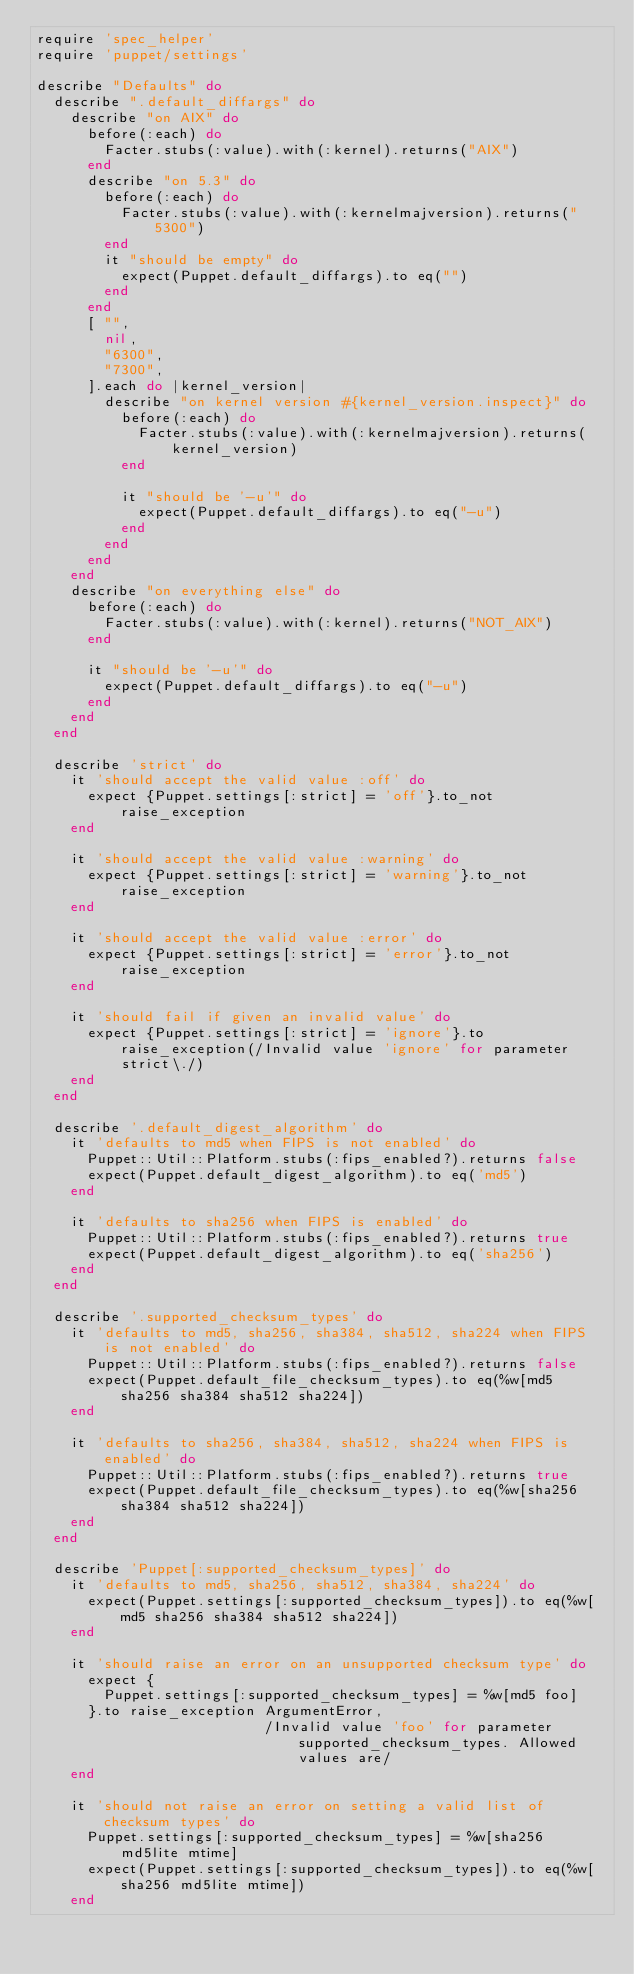Convert code to text. <code><loc_0><loc_0><loc_500><loc_500><_Ruby_>require 'spec_helper'
require 'puppet/settings'

describe "Defaults" do
  describe ".default_diffargs" do
    describe "on AIX" do
      before(:each) do
        Facter.stubs(:value).with(:kernel).returns("AIX")
      end
      describe "on 5.3" do
        before(:each) do
          Facter.stubs(:value).with(:kernelmajversion).returns("5300")
        end
        it "should be empty" do
          expect(Puppet.default_diffargs).to eq("")
        end
      end
      [ "",
        nil,
        "6300",
        "7300",
      ].each do |kernel_version|
        describe "on kernel version #{kernel_version.inspect}" do
          before(:each) do
            Facter.stubs(:value).with(:kernelmajversion).returns(kernel_version)
          end

          it "should be '-u'" do
            expect(Puppet.default_diffargs).to eq("-u")
          end
        end
      end
    end
    describe "on everything else" do
      before(:each) do
        Facter.stubs(:value).with(:kernel).returns("NOT_AIX")
      end

      it "should be '-u'" do
        expect(Puppet.default_diffargs).to eq("-u")
      end
    end
  end

  describe 'strict' do
    it 'should accept the valid value :off' do
      expect {Puppet.settings[:strict] = 'off'}.to_not raise_exception
    end

    it 'should accept the valid value :warning' do
      expect {Puppet.settings[:strict] = 'warning'}.to_not raise_exception
    end

    it 'should accept the valid value :error' do
      expect {Puppet.settings[:strict] = 'error'}.to_not raise_exception
    end

    it 'should fail if given an invalid value' do
      expect {Puppet.settings[:strict] = 'ignore'}.to raise_exception(/Invalid value 'ignore' for parameter strict\./)
    end
  end

  describe '.default_digest_algorithm' do
    it 'defaults to md5 when FIPS is not enabled' do
      Puppet::Util::Platform.stubs(:fips_enabled?).returns false
      expect(Puppet.default_digest_algorithm).to eq('md5')
    end

    it 'defaults to sha256 when FIPS is enabled' do
      Puppet::Util::Platform.stubs(:fips_enabled?).returns true
      expect(Puppet.default_digest_algorithm).to eq('sha256')
    end
  end

  describe '.supported_checksum_types' do
    it 'defaults to md5, sha256, sha384, sha512, sha224 when FIPS is not enabled' do
      Puppet::Util::Platform.stubs(:fips_enabled?).returns false
      expect(Puppet.default_file_checksum_types).to eq(%w[md5 sha256 sha384 sha512 sha224])
    end

    it 'defaults to sha256, sha384, sha512, sha224 when FIPS is enabled' do
      Puppet::Util::Platform.stubs(:fips_enabled?).returns true
      expect(Puppet.default_file_checksum_types).to eq(%w[sha256 sha384 sha512 sha224])
    end
  end

  describe 'Puppet[:supported_checksum_types]' do
    it 'defaults to md5, sha256, sha512, sha384, sha224' do
      expect(Puppet.settings[:supported_checksum_types]).to eq(%w[md5 sha256 sha384 sha512 sha224])
    end

    it 'should raise an error on an unsupported checksum type' do
      expect {
        Puppet.settings[:supported_checksum_types] = %w[md5 foo]
      }.to raise_exception ArgumentError,
                           /Invalid value 'foo' for parameter supported_checksum_types. Allowed values are/
    end

    it 'should not raise an error on setting a valid list of checksum types' do
      Puppet.settings[:supported_checksum_types] = %w[sha256 md5lite mtime]
      expect(Puppet.settings[:supported_checksum_types]).to eq(%w[sha256 md5lite mtime])
    end
</code> 